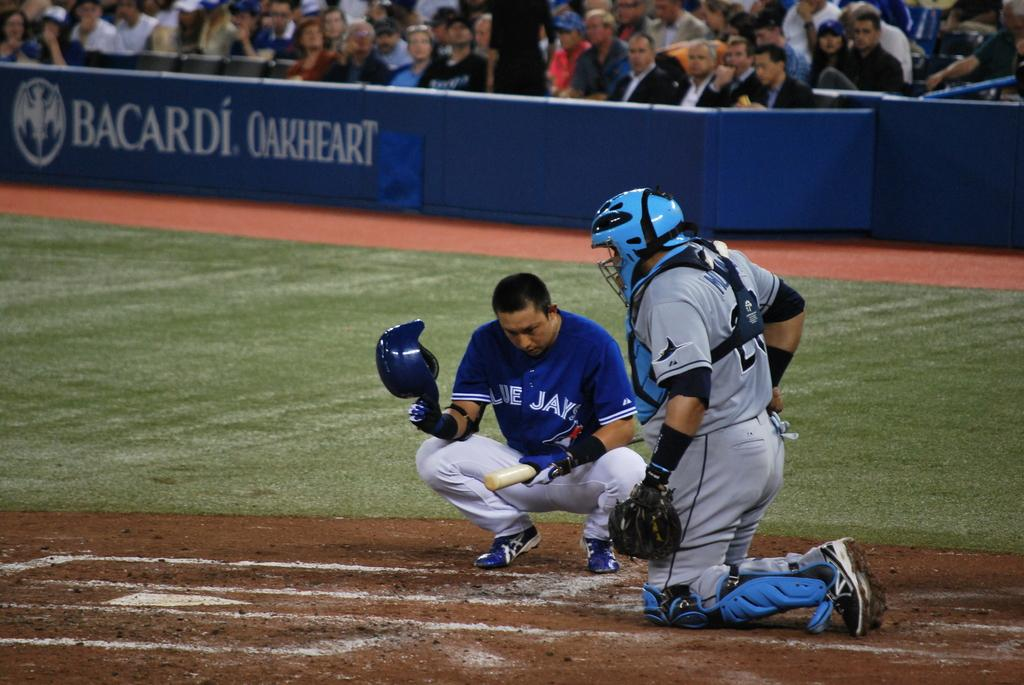Provide a one-sentence caption for the provided image. A Blue Jays baseball player squats in front of the catcher before batting. 